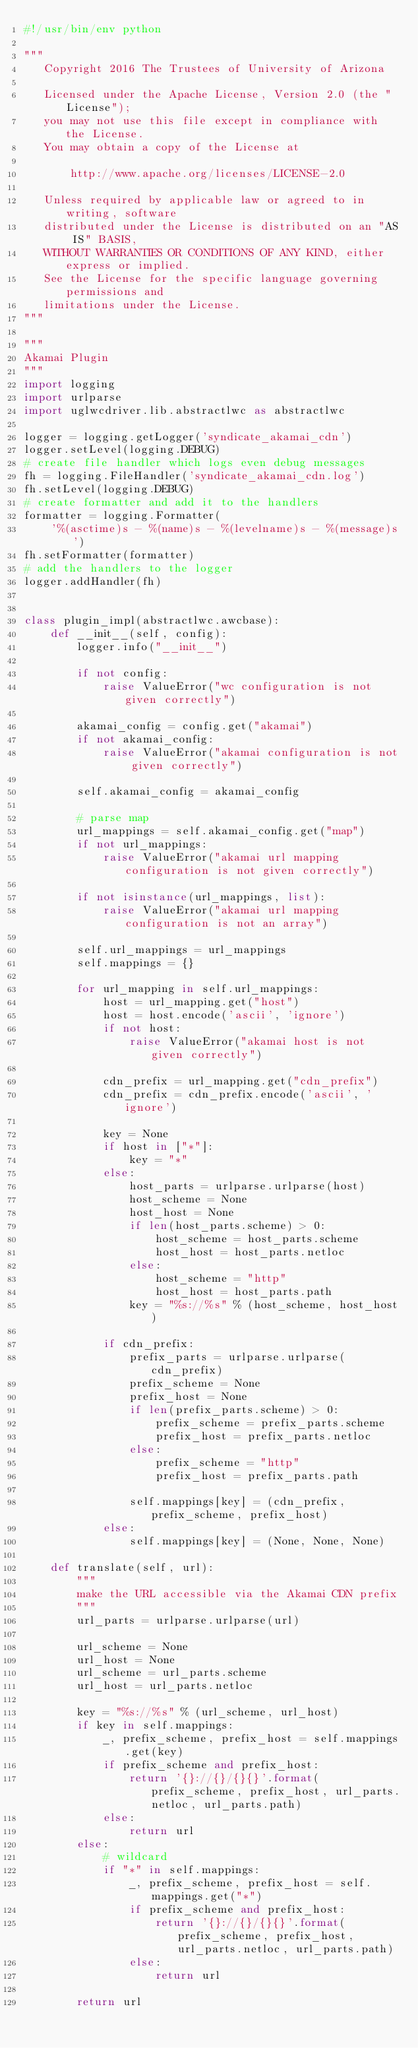<code> <loc_0><loc_0><loc_500><loc_500><_Python_>#!/usr/bin/env python

"""
   Copyright 2016 The Trustees of University of Arizona

   Licensed under the Apache License, Version 2.0 (the "License");
   you may not use this file except in compliance with the License.
   You may obtain a copy of the License at

       http://www.apache.org/licenses/LICENSE-2.0

   Unless required by applicable law or agreed to in writing, software
   distributed under the License is distributed on an "AS IS" BASIS,
   WITHOUT WARRANTIES OR CONDITIONS OF ANY KIND, either express or implied.
   See the License for the specific language governing permissions and
   limitations under the License.
"""

"""
Akamai Plugin
"""
import logging
import urlparse
import uglwcdriver.lib.abstractlwc as abstractlwc

logger = logging.getLogger('syndicate_akamai_cdn')
logger.setLevel(logging.DEBUG)
# create file handler which logs even debug messages
fh = logging.FileHandler('syndicate_akamai_cdn.log')
fh.setLevel(logging.DEBUG)
# create formatter and add it to the handlers
formatter = logging.Formatter(
    '%(asctime)s - %(name)s - %(levelname)s - %(message)s')
fh.setFormatter(formatter)
# add the handlers to the logger
logger.addHandler(fh)


class plugin_impl(abstractlwc.awcbase):
    def __init__(self, config):
        logger.info("__init__")

        if not config:
            raise ValueError("wc configuration is not given correctly")

        akamai_config = config.get("akamai")
        if not akamai_config:
            raise ValueError("akamai configuration is not given correctly")

        self.akamai_config = akamai_config

        # parse map
        url_mappings = self.akamai_config.get("map")
        if not url_mappings:
            raise ValueError("akamai url mapping configuration is not given correctly")

        if not isinstance(url_mappings, list):
            raise ValueError("akamai url mapping configuration is not an array")

        self.url_mappings = url_mappings
        self.mappings = {}

        for url_mapping in self.url_mappings:
            host = url_mapping.get("host")
            host = host.encode('ascii', 'ignore')
            if not host:
                raise ValueError("akamai host is not given correctly")

            cdn_prefix = url_mapping.get("cdn_prefix")
            cdn_prefix = cdn_prefix.encode('ascii', 'ignore')

            key = None
            if host in ["*"]:
                key = "*"
            else:
                host_parts = urlparse.urlparse(host)
                host_scheme = None
                host_host = None
                if len(host_parts.scheme) > 0:
                    host_scheme = host_parts.scheme
                    host_host = host_parts.netloc
                else:
                    host_scheme = "http"
                    host_host = host_parts.path
                key = "%s://%s" % (host_scheme, host_host)

            if cdn_prefix:
                prefix_parts = urlparse.urlparse(cdn_prefix)
                prefix_scheme = None
                prefix_host = None
                if len(prefix_parts.scheme) > 0:
                    prefix_scheme = prefix_parts.scheme
                    prefix_host = prefix_parts.netloc
                else:
                    prefix_scheme = "http"
                    prefix_host = prefix_parts.path

                self.mappings[key] = (cdn_prefix, prefix_scheme, prefix_host)
            else:
                self.mappings[key] = (None, None, None)

    def translate(self, url):
        """
        make the URL accessible via the Akamai CDN prefix
        """
        url_parts = urlparse.urlparse(url)

        url_scheme = None
        url_host = None
        url_scheme = url_parts.scheme
        url_host = url_parts.netloc

        key = "%s://%s" % (url_scheme, url_host)
        if key in self.mappings:
            _, prefix_scheme, prefix_host = self.mappings.get(key)
            if prefix_scheme and prefix_host:
                return '{}://{}/{}{}'.format(prefix_scheme, prefix_host, url_parts.netloc, url_parts.path)
            else:
                return url
        else:
            # wildcard
            if "*" in self.mappings:
                _, prefix_scheme, prefix_host = self.mappings.get("*")
                if prefix_scheme and prefix_host:
                    return '{}://{}/{}{}'.format(prefix_scheme, prefix_host, url_parts.netloc, url_parts.path)
                else:
                    return url

        return url
</code> 